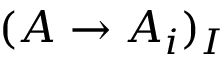Convert formula to latex. <formula><loc_0><loc_0><loc_500><loc_500>( A \to A _ { i } ) _ { I }</formula> 